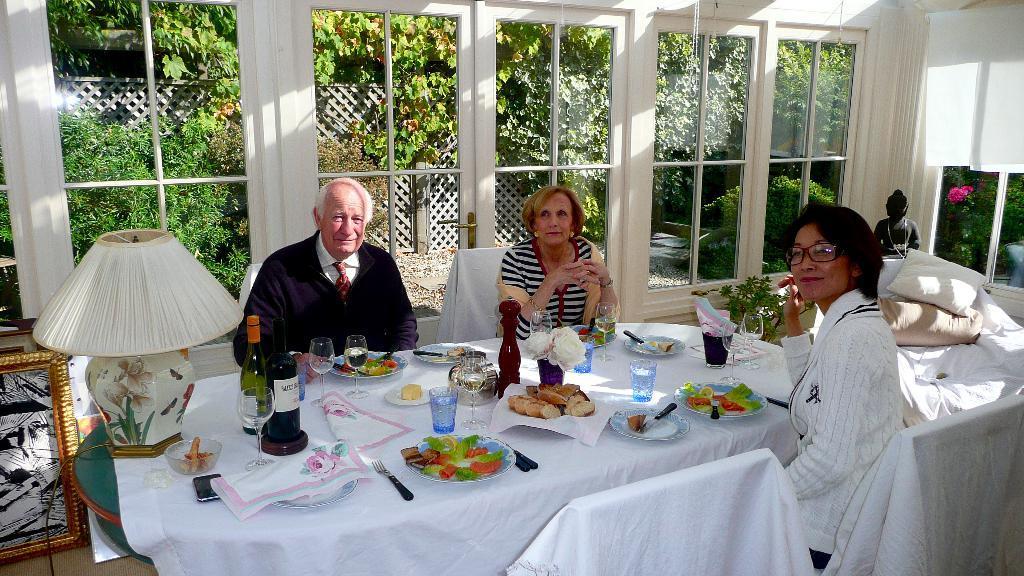Please provide a concise description of this image. On the background of the picture we can see few trees and plants. this is a door. we can see windows. Here we can see one statue. Here we can see few persons sitting on a chairs in front of a table and on the table we can see Spoons and forks, tissue papers, bottles, glasses, flower vase and also a plate of food. 